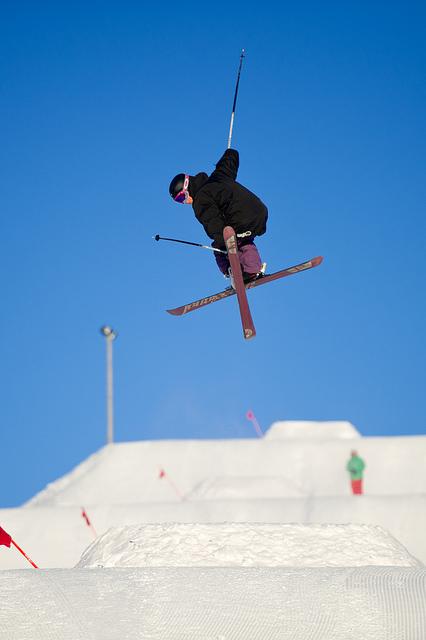Is this person skiing?
Keep it brief. Yes. Is the person going to injure himself?
Answer briefly. No. Is he professional?
Keep it brief. Yes. How many people are jumping?
Concise answer only. 1. 